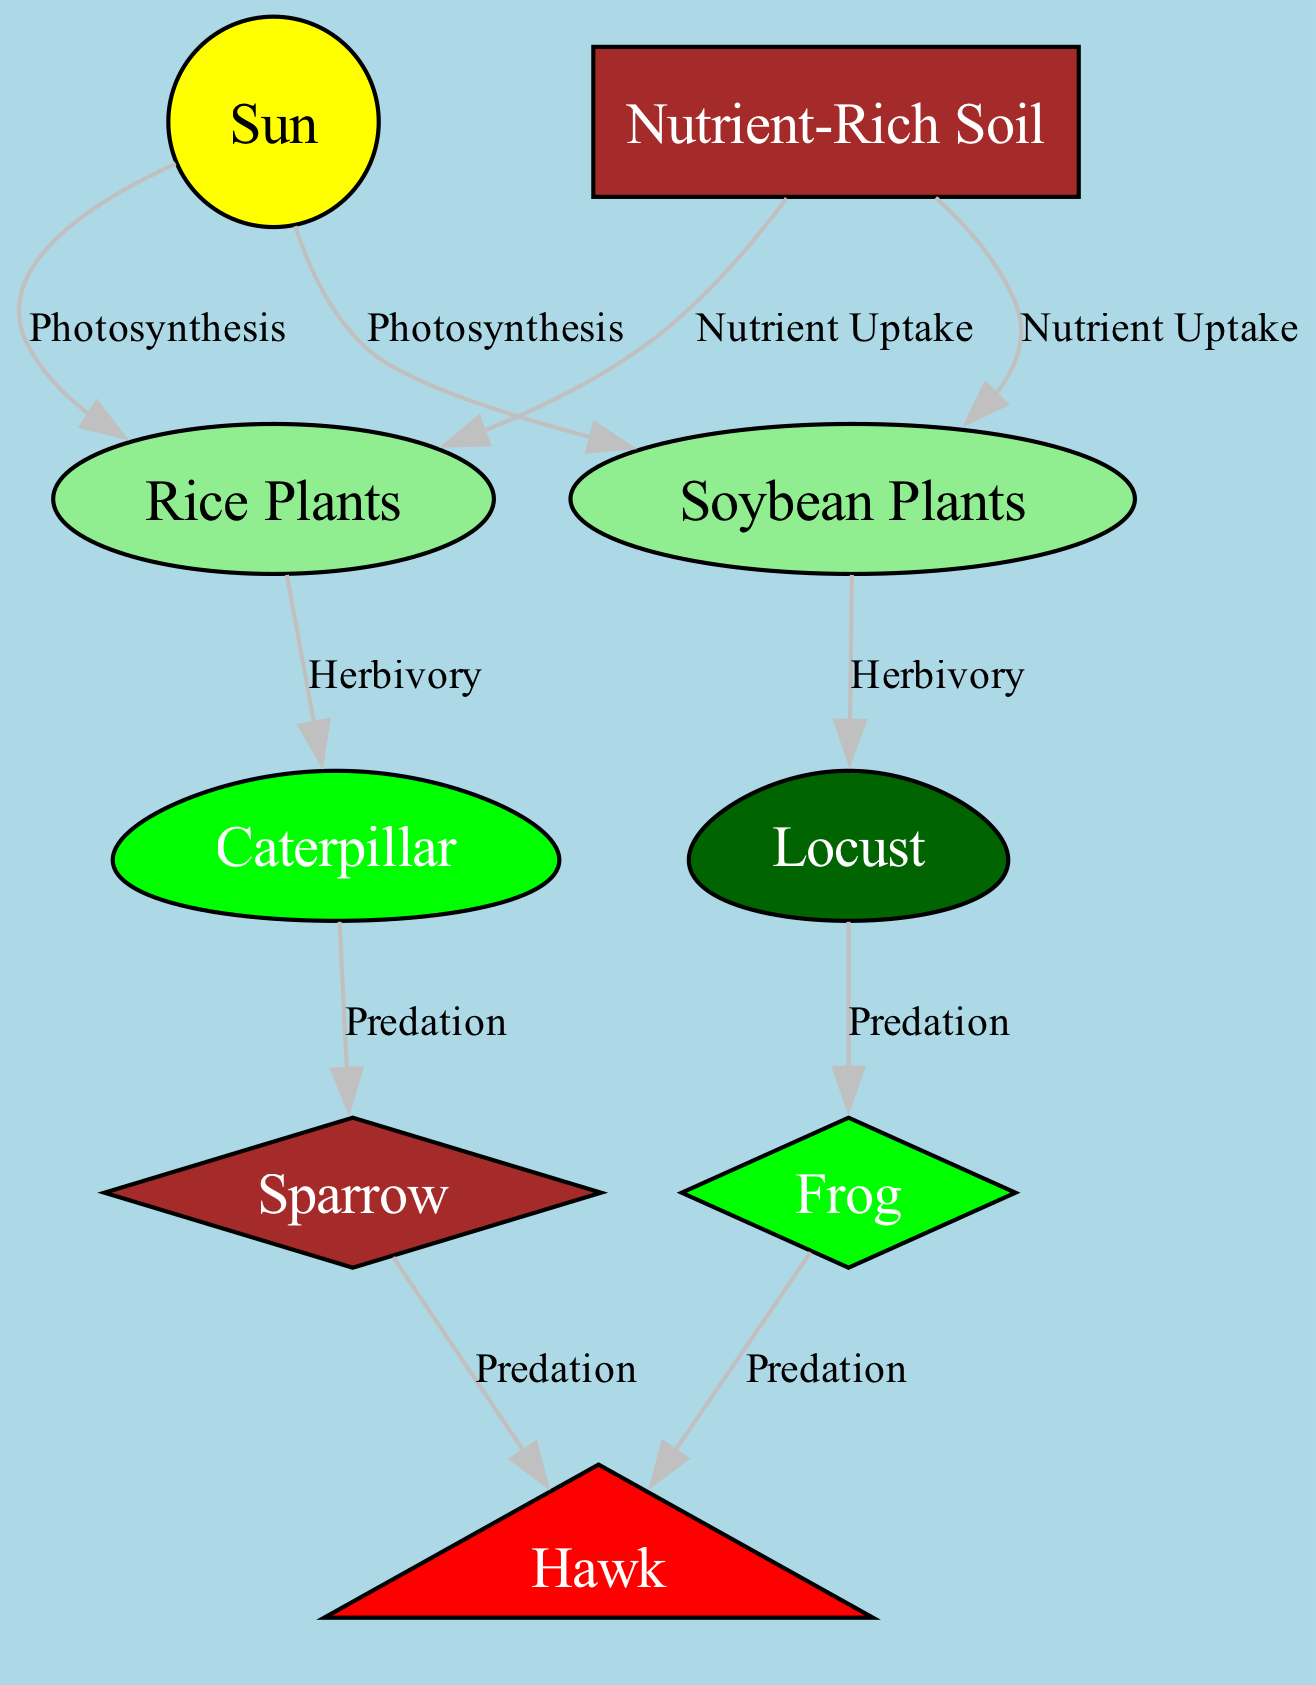What is the starting point of the food chain? The food chain starts with the "Sun" as it is the initial node from which energy flows into the system through photosynthesis.
Answer: Sun How many nodes are there in the diagram? By counting each unique entity that is represented in the diagram, we find there are a total of nine nodes listed.
Answer: 9 Which insect eats rice plants? The diagram shows that the "Caterpillar" consumes "Rice Plants," making it the insect that eats this particular crop.
Answer: Caterpillar What type of relationship exists between beans and locusts? The relationship is defined as "Herbivory," indicating that locusts feed on soybean plants in the food chain.
Answer: Herbivory What organism preys on sparrows? According to the diagram, the "Hawk" preys on "Sparrow," which shows its role as a predator in the food chain.
Answer: Hawk How are rice plants affected by sunlight? The relationship is established as "Photosynthesis," where rice plants directly utilize sunlight to create energy.
Answer: Photosynthesis Which two predators exist in the food chain? The two predators identified in the diagram are the "Hawk" and the "Frog," both of which feed on other organisms.
Answer: Hawk and Frog What happens to locusts in the food chain? The diagram shows that the "Locust" is predated by "Frog," indicating its role in the chain as a prey species.
Answer: Preyed by Frog What role does nutrient-rich soil play in crop growth? The soil is essential for "Nutrient Uptake," allowing both rice and soybean plants to grow successfully by obtaining nutrients from the soil.
Answer: Nutrient Uptake 